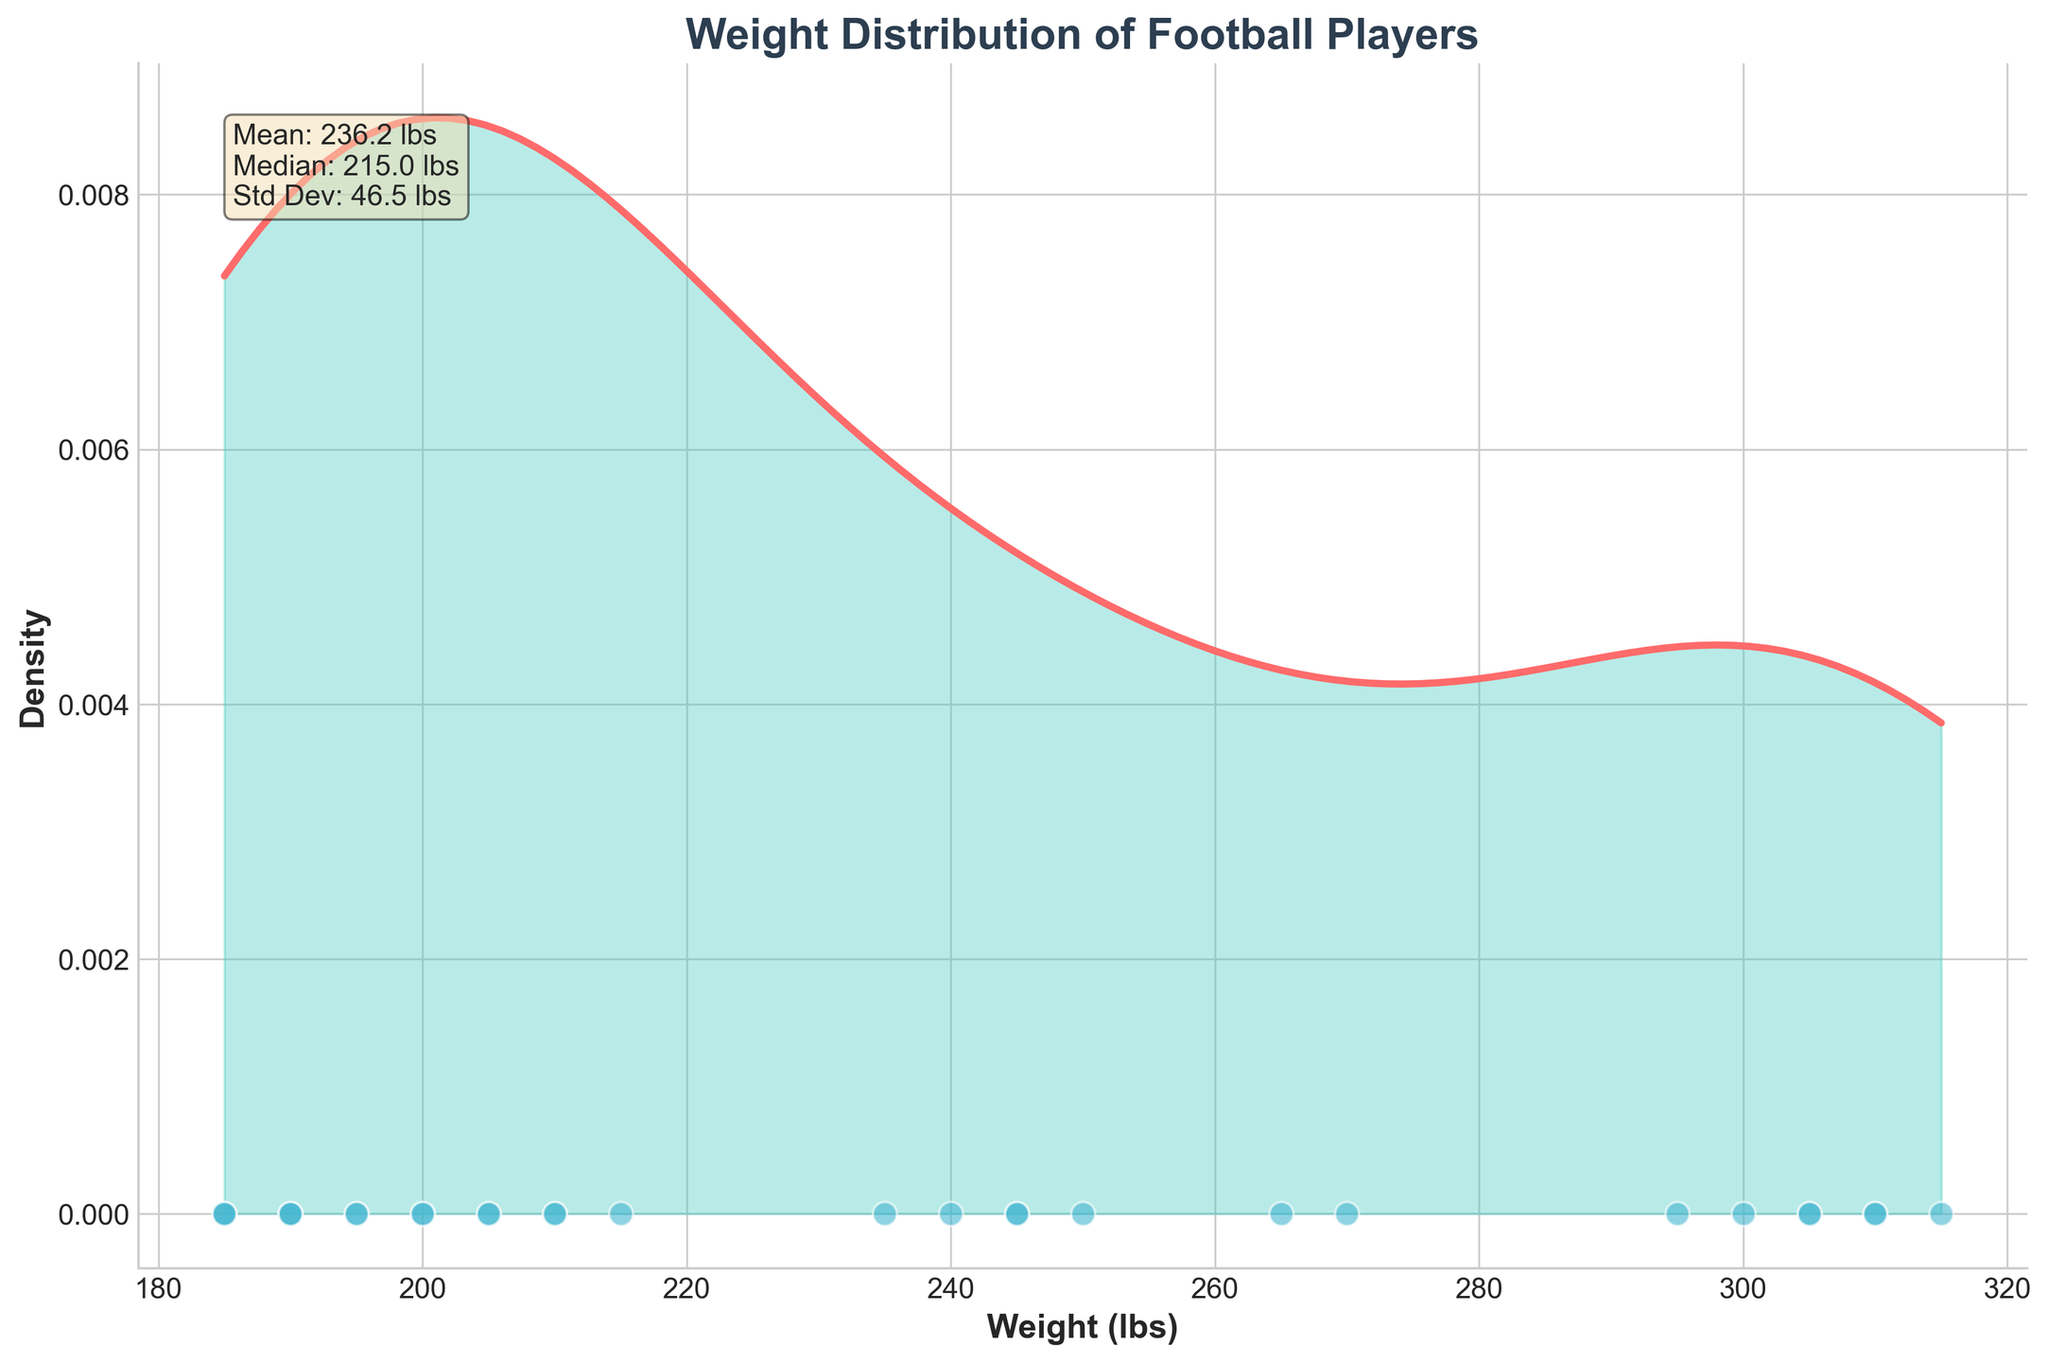What's the title of the plot? The title is located at the top of the plot and is typically in a larger, bold font color. It provides an overview of what the plot is about.
Answer: Weight Distribution of Football Players What does the x-axis represent? The x-axis runs horizontally along the bottom of the plot and is labeled to provide context. In this case, it indicates the variable being measured.
Answer: Weight (lbs) What does the y-axis represent? The y-axis runs vertically along the left side of the plot, and it is labeled to show the concept being quantified, in this case, it shows the density.
Answer: Density What is the mean weight of the football players? The mean weight is provided in the text box at the top left corner of the plot. Mean is the average value of the weights.
Answer: 235.0 lbs What is the median weight of the football players? The median weight is given in the text box in the top left corner of the plot. The median is the middle value when the data is ordered.
Answer: 240.0 lbs What is the standard deviation of the football players' weights? The standard deviation is also provided in the text box. It measures the amount of variation in the data.
Answer: 43.8 lbs How is the density curve represented visually in the plot? The density curve is the primary focus of the plot, displayed as a smooth, continuous line with a fill underneath. The color and style help it to stand out.
Answer: A smooth line with a color fill underneath How many scatter points are there at the bottom of the plot? Scatter points represent individual data points. They are shown as dots at the bottom of the plot. You can count them directly.
Answer: 29 scatter points Based on the density plot, which weight range appears to have the highest density of players? The highest density is where the curve reaches its peak. You can observe the x-axis position at this peak point.
Answer: Around 300 lbs Are the weights of football players more concentrated around a particular value, indicated by the median and mean? Reviewing both the median and mean values in the statistics box will help to determine if the data is more concentrated around these values or scattered. Since both are close to 240 lbs, the concentration is around this value.
Answer: Around 240 lbs 